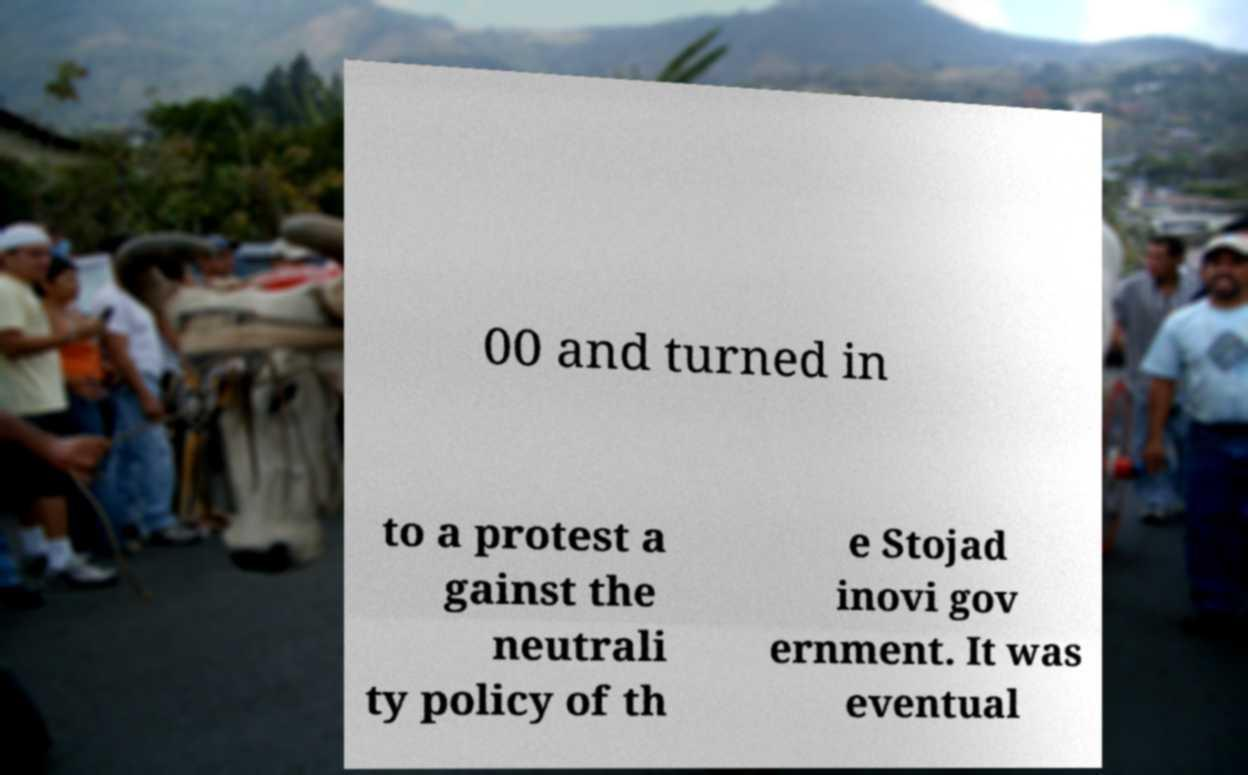Please read and relay the text visible in this image. What does it say? 00 and turned in to a protest a gainst the neutrali ty policy of th e Stojad inovi gov ernment. It was eventual 